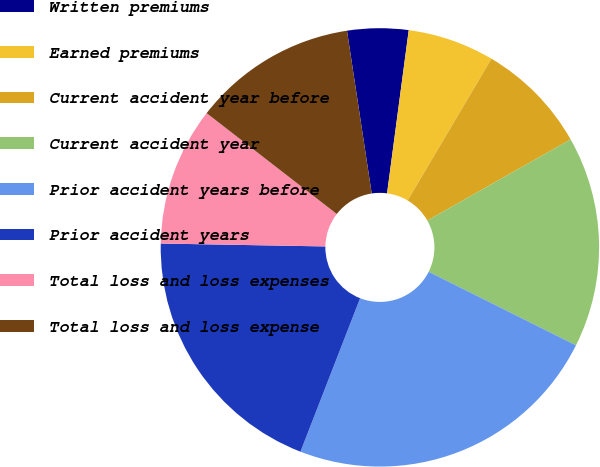Convert chart. <chart><loc_0><loc_0><loc_500><loc_500><pie_chart><fcel>Written premiums<fcel>Earned premiums<fcel>Current accident year before<fcel>Current accident year<fcel>Prior accident years before<fcel>Prior accident years<fcel>Total loss and loss expenses<fcel>Total loss and loss expense<nl><fcel>4.5%<fcel>6.4%<fcel>8.3%<fcel>15.57%<fcel>23.53%<fcel>19.38%<fcel>10.21%<fcel>12.11%<nl></chart> 